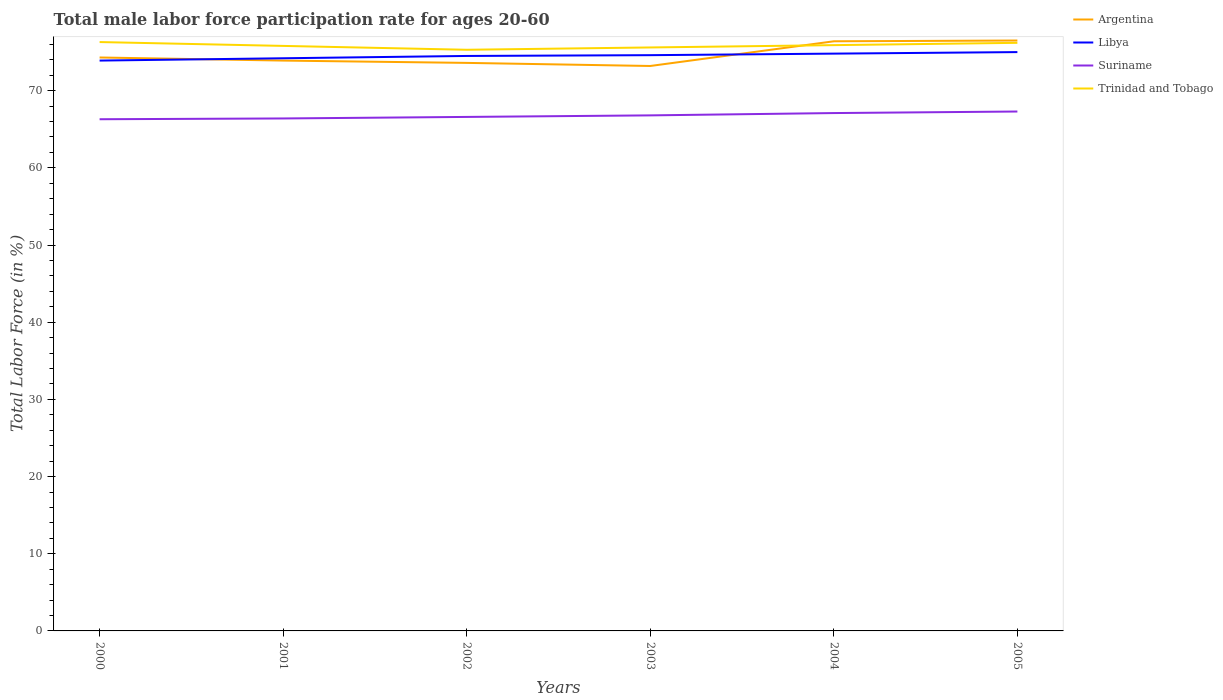Does the line corresponding to Trinidad and Tobago intersect with the line corresponding to Suriname?
Provide a short and direct response. No. Is the number of lines equal to the number of legend labels?
Make the answer very short. Yes. Across all years, what is the maximum male labor force participation rate in Argentina?
Keep it short and to the point. 73.2. What is the total male labor force participation rate in Suriname in the graph?
Your response must be concise. -0.3. What is the difference between the highest and the second highest male labor force participation rate in Libya?
Provide a short and direct response. 1.1. What is the difference between the highest and the lowest male labor force participation rate in Trinidad and Tobago?
Give a very brief answer. 3. How many lines are there?
Ensure brevity in your answer.  4. Where does the legend appear in the graph?
Provide a succinct answer. Top right. How many legend labels are there?
Provide a succinct answer. 4. What is the title of the graph?
Provide a succinct answer. Total male labor force participation rate for ages 20-60. Does "Ireland" appear as one of the legend labels in the graph?
Ensure brevity in your answer.  No. What is the label or title of the X-axis?
Offer a very short reply. Years. What is the label or title of the Y-axis?
Provide a short and direct response. Total Labor Force (in %). What is the Total Labor Force (in %) of Argentina in 2000?
Provide a short and direct response. 74.3. What is the Total Labor Force (in %) in Libya in 2000?
Give a very brief answer. 73.9. What is the Total Labor Force (in %) of Suriname in 2000?
Provide a short and direct response. 66.3. What is the Total Labor Force (in %) of Trinidad and Tobago in 2000?
Offer a terse response. 76.3. What is the Total Labor Force (in %) of Argentina in 2001?
Provide a short and direct response. 73.9. What is the Total Labor Force (in %) in Libya in 2001?
Make the answer very short. 74.2. What is the Total Labor Force (in %) in Suriname in 2001?
Offer a terse response. 66.4. What is the Total Labor Force (in %) in Trinidad and Tobago in 2001?
Keep it short and to the point. 75.8. What is the Total Labor Force (in %) of Argentina in 2002?
Make the answer very short. 73.6. What is the Total Labor Force (in %) in Libya in 2002?
Provide a succinct answer. 74.5. What is the Total Labor Force (in %) of Suriname in 2002?
Give a very brief answer. 66.6. What is the Total Labor Force (in %) in Trinidad and Tobago in 2002?
Make the answer very short. 75.3. What is the Total Labor Force (in %) of Argentina in 2003?
Make the answer very short. 73.2. What is the Total Labor Force (in %) of Libya in 2003?
Ensure brevity in your answer.  74.6. What is the Total Labor Force (in %) of Suriname in 2003?
Your response must be concise. 66.8. What is the Total Labor Force (in %) in Trinidad and Tobago in 2003?
Ensure brevity in your answer.  75.6. What is the Total Labor Force (in %) of Argentina in 2004?
Your response must be concise. 76.4. What is the Total Labor Force (in %) of Libya in 2004?
Keep it short and to the point. 74.8. What is the Total Labor Force (in %) of Suriname in 2004?
Ensure brevity in your answer.  67.1. What is the Total Labor Force (in %) in Trinidad and Tobago in 2004?
Ensure brevity in your answer.  75.9. What is the Total Labor Force (in %) in Argentina in 2005?
Make the answer very short. 76.5. What is the Total Labor Force (in %) of Suriname in 2005?
Make the answer very short. 67.3. What is the Total Labor Force (in %) in Trinidad and Tobago in 2005?
Your answer should be very brief. 76.2. Across all years, what is the maximum Total Labor Force (in %) of Argentina?
Your response must be concise. 76.5. Across all years, what is the maximum Total Labor Force (in %) of Suriname?
Provide a short and direct response. 67.3. Across all years, what is the maximum Total Labor Force (in %) in Trinidad and Tobago?
Make the answer very short. 76.3. Across all years, what is the minimum Total Labor Force (in %) of Argentina?
Ensure brevity in your answer.  73.2. Across all years, what is the minimum Total Labor Force (in %) of Libya?
Your response must be concise. 73.9. Across all years, what is the minimum Total Labor Force (in %) in Suriname?
Your response must be concise. 66.3. Across all years, what is the minimum Total Labor Force (in %) in Trinidad and Tobago?
Ensure brevity in your answer.  75.3. What is the total Total Labor Force (in %) of Argentina in the graph?
Your answer should be very brief. 447.9. What is the total Total Labor Force (in %) of Libya in the graph?
Your answer should be compact. 447. What is the total Total Labor Force (in %) of Suriname in the graph?
Your answer should be compact. 400.5. What is the total Total Labor Force (in %) in Trinidad and Tobago in the graph?
Keep it short and to the point. 455.1. What is the difference between the Total Labor Force (in %) in Argentina in 2000 and that in 2001?
Provide a short and direct response. 0.4. What is the difference between the Total Labor Force (in %) of Libya in 2000 and that in 2001?
Make the answer very short. -0.3. What is the difference between the Total Labor Force (in %) in Libya in 2000 and that in 2002?
Provide a short and direct response. -0.6. What is the difference between the Total Labor Force (in %) in Suriname in 2000 and that in 2002?
Offer a very short reply. -0.3. What is the difference between the Total Labor Force (in %) of Trinidad and Tobago in 2000 and that in 2002?
Make the answer very short. 1. What is the difference between the Total Labor Force (in %) of Libya in 2000 and that in 2003?
Keep it short and to the point. -0.7. What is the difference between the Total Labor Force (in %) in Argentina in 2000 and that in 2004?
Give a very brief answer. -2.1. What is the difference between the Total Labor Force (in %) in Libya in 2000 and that in 2004?
Your answer should be very brief. -0.9. What is the difference between the Total Labor Force (in %) of Suriname in 2000 and that in 2004?
Provide a succinct answer. -0.8. What is the difference between the Total Labor Force (in %) of Trinidad and Tobago in 2000 and that in 2004?
Give a very brief answer. 0.4. What is the difference between the Total Labor Force (in %) in Argentina in 2000 and that in 2005?
Give a very brief answer. -2.2. What is the difference between the Total Labor Force (in %) of Argentina in 2001 and that in 2002?
Offer a terse response. 0.3. What is the difference between the Total Labor Force (in %) of Libya in 2001 and that in 2002?
Offer a terse response. -0.3. What is the difference between the Total Labor Force (in %) of Trinidad and Tobago in 2001 and that in 2002?
Offer a terse response. 0.5. What is the difference between the Total Labor Force (in %) of Trinidad and Tobago in 2001 and that in 2003?
Offer a terse response. 0.2. What is the difference between the Total Labor Force (in %) of Libya in 2001 and that in 2004?
Provide a succinct answer. -0.6. What is the difference between the Total Labor Force (in %) of Suriname in 2001 and that in 2004?
Your answer should be compact. -0.7. What is the difference between the Total Labor Force (in %) of Argentina in 2001 and that in 2005?
Keep it short and to the point. -2.6. What is the difference between the Total Labor Force (in %) of Trinidad and Tobago in 2001 and that in 2005?
Make the answer very short. -0.4. What is the difference between the Total Labor Force (in %) of Libya in 2002 and that in 2003?
Keep it short and to the point. -0.1. What is the difference between the Total Labor Force (in %) of Suriname in 2002 and that in 2003?
Provide a short and direct response. -0.2. What is the difference between the Total Labor Force (in %) in Trinidad and Tobago in 2002 and that in 2003?
Provide a succinct answer. -0.3. What is the difference between the Total Labor Force (in %) in Libya in 2002 and that in 2004?
Your answer should be very brief. -0.3. What is the difference between the Total Labor Force (in %) in Suriname in 2002 and that in 2004?
Make the answer very short. -0.5. What is the difference between the Total Labor Force (in %) in Argentina in 2002 and that in 2005?
Keep it short and to the point. -2.9. What is the difference between the Total Labor Force (in %) of Suriname in 2002 and that in 2005?
Offer a terse response. -0.7. What is the difference between the Total Labor Force (in %) of Libya in 2003 and that in 2004?
Offer a very short reply. -0.2. What is the difference between the Total Labor Force (in %) in Suriname in 2003 and that in 2004?
Your answer should be very brief. -0.3. What is the difference between the Total Labor Force (in %) in Trinidad and Tobago in 2003 and that in 2004?
Provide a succinct answer. -0.3. What is the difference between the Total Labor Force (in %) in Argentina in 2004 and that in 2005?
Offer a terse response. -0.1. What is the difference between the Total Labor Force (in %) of Libya in 2004 and that in 2005?
Make the answer very short. -0.2. What is the difference between the Total Labor Force (in %) of Suriname in 2004 and that in 2005?
Your answer should be compact. -0.2. What is the difference between the Total Labor Force (in %) of Trinidad and Tobago in 2004 and that in 2005?
Your answer should be very brief. -0.3. What is the difference between the Total Labor Force (in %) in Argentina in 2000 and the Total Labor Force (in %) in Libya in 2001?
Provide a short and direct response. 0.1. What is the difference between the Total Labor Force (in %) in Argentina in 2000 and the Total Labor Force (in %) in Trinidad and Tobago in 2001?
Offer a terse response. -1.5. What is the difference between the Total Labor Force (in %) in Libya in 2000 and the Total Labor Force (in %) in Trinidad and Tobago in 2001?
Offer a very short reply. -1.9. What is the difference between the Total Labor Force (in %) of Suriname in 2000 and the Total Labor Force (in %) of Trinidad and Tobago in 2001?
Ensure brevity in your answer.  -9.5. What is the difference between the Total Labor Force (in %) of Argentina in 2000 and the Total Labor Force (in %) of Suriname in 2002?
Provide a succinct answer. 7.7. What is the difference between the Total Labor Force (in %) of Argentina in 2000 and the Total Labor Force (in %) of Trinidad and Tobago in 2002?
Keep it short and to the point. -1. What is the difference between the Total Labor Force (in %) of Libya in 2000 and the Total Labor Force (in %) of Suriname in 2002?
Make the answer very short. 7.3. What is the difference between the Total Labor Force (in %) of Libya in 2000 and the Total Labor Force (in %) of Trinidad and Tobago in 2002?
Offer a very short reply. -1.4. What is the difference between the Total Labor Force (in %) of Suriname in 2000 and the Total Labor Force (in %) of Trinidad and Tobago in 2002?
Ensure brevity in your answer.  -9. What is the difference between the Total Labor Force (in %) of Argentina in 2000 and the Total Labor Force (in %) of Libya in 2003?
Offer a very short reply. -0.3. What is the difference between the Total Labor Force (in %) of Libya in 2000 and the Total Labor Force (in %) of Trinidad and Tobago in 2003?
Your response must be concise. -1.7. What is the difference between the Total Labor Force (in %) of Suriname in 2000 and the Total Labor Force (in %) of Trinidad and Tobago in 2003?
Your answer should be very brief. -9.3. What is the difference between the Total Labor Force (in %) of Argentina in 2000 and the Total Labor Force (in %) of Libya in 2004?
Your response must be concise. -0.5. What is the difference between the Total Labor Force (in %) of Argentina in 2000 and the Total Labor Force (in %) of Suriname in 2004?
Make the answer very short. 7.2. What is the difference between the Total Labor Force (in %) in Argentina in 2000 and the Total Labor Force (in %) in Trinidad and Tobago in 2004?
Your response must be concise. -1.6. What is the difference between the Total Labor Force (in %) of Libya in 2000 and the Total Labor Force (in %) of Trinidad and Tobago in 2004?
Give a very brief answer. -2. What is the difference between the Total Labor Force (in %) of Suriname in 2000 and the Total Labor Force (in %) of Trinidad and Tobago in 2004?
Your response must be concise. -9.6. What is the difference between the Total Labor Force (in %) in Argentina in 2000 and the Total Labor Force (in %) in Libya in 2005?
Offer a very short reply. -0.7. What is the difference between the Total Labor Force (in %) in Argentina in 2000 and the Total Labor Force (in %) in Suriname in 2005?
Offer a very short reply. 7. What is the difference between the Total Labor Force (in %) in Argentina in 2000 and the Total Labor Force (in %) in Trinidad and Tobago in 2005?
Provide a short and direct response. -1.9. What is the difference between the Total Labor Force (in %) of Libya in 2000 and the Total Labor Force (in %) of Suriname in 2005?
Offer a very short reply. 6.6. What is the difference between the Total Labor Force (in %) of Libya in 2000 and the Total Labor Force (in %) of Trinidad and Tobago in 2005?
Your response must be concise. -2.3. What is the difference between the Total Labor Force (in %) of Argentina in 2001 and the Total Labor Force (in %) of Trinidad and Tobago in 2002?
Your answer should be very brief. -1.4. What is the difference between the Total Labor Force (in %) in Libya in 2001 and the Total Labor Force (in %) in Trinidad and Tobago in 2002?
Provide a short and direct response. -1.1. What is the difference between the Total Labor Force (in %) of Argentina in 2001 and the Total Labor Force (in %) of Suriname in 2003?
Provide a short and direct response. 7.1. What is the difference between the Total Labor Force (in %) of Argentina in 2001 and the Total Labor Force (in %) of Trinidad and Tobago in 2003?
Provide a succinct answer. -1.7. What is the difference between the Total Labor Force (in %) of Libya in 2001 and the Total Labor Force (in %) of Suriname in 2003?
Offer a terse response. 7.4. What is the difference between the Total Labor Force (in %) of Argentina in 2001 and the Total Labor Force (in %) of Trinidad and Tobago in 2004?
Provide a short and direct response. -2. What is the difference between the Total Labor Force (in %) of Libya in 2001 and the Total Labor Force (in %) of Suriname in 2004?
Offer a very short reply. 7.1. What is the difference between the Total Labor Force (in %) in Libya in 2001 and the Total Labor Force (in %) in Trinidad and Tobago in 2004?
Your answer should be very brief. -1.7. What is the difference between the Total Labor Force (in %) in Suriname in 2001 and the Total Labor Force (in %) in Trinidad and Tobago in 2004?
Your response must be concise. -9.5. What is the difference between the Total Labor Force (in %) of Argentina in 2001 and the Total Labor Force (in %) of Suriname in 2005?
Give a very brief answer. 6.6. What is the difference between the Total Labor Force (in %) of Suriname in 2001 and the Total Labor Force (in %) of Trinidad and Tobago in 2005?
Ensure brevity in your answer.  -9.8. What is the difference between the Total Labor Force (in %) in Argentina in 2002 and the Total Labor Force (in %) in Libya in 2004?
Offer a terse response. -1.2. What is the difference between the Total Labor Force (in %) in Libya in 2002 and the Total Labor Force (in %) in Suriname in 2004?
Offer a terse response. 7.4. What is the difference between the Total Labor Force (in %) in Suriname in 2002 and the Total Labor Force (in %) in Trinidad and Tobago in 2004?
Offer a terse response. -9.3. What is the difference between the Total Labor Force (in %) in Argentina in 2002 and the Total Labor Force (in %) in Suriname in 2005?
Your answer should be compact. 6.3. What is the difference between the Total Labor Force (in %) of Argentina in 2002 and the Total Labor Force (in %) of Trinidad and Tobago in 2005?
Your response must be concise. -2.6. What is the difference between the Total Labor Force (in %) of Libya in 2002 and the Total Labor Force (in %) of Trinidad and Tobago in 2005?
Make the answer very short. -1.7. What is the difference between the Total Labor Force (in %) of Suriname in 2002 and the Total Labor Force (in %) of Trinidad and Tobago in 2005?
Ensure brevity in your answer.  -9.6. What is the difference between the Total Labor Force (in %) of Argentina in 2003 and the Total Labor Force (in %) of Libya in 2004?
Offer a terse response. -1.6. What is the difference between the Total Labor Force (in %) of Suriname in 2003 and the Total Labor Force (in %) of Trinidad and Tobago in 2004?
Make the answer very short. -9.1. What is the difference between the Total Labor Force (in %) in Argentina in 2003 and the Total Labor Force (in %) in Suriname in 2005?
Offer a very short reply. 5.9. What is the difference between the Total Labor Force (in %) in Argentina in 2003 and the Total Labor Force (in %) in Trinidad and Tobago in 2005?
Offer a very short reply. -3. What is the difference between the Total Labor Force (in %) in Argentina in 2004 and the Total Labor Force (in %) in Libya in 2005?
Ensure brevity in your answer.  1.4. What is the difference between the Total Labor Force (in %) of Argentina in 2004 and the Total Labor Force (in %) of Trinidad and Tobago in 2005?
Your response must be concise. 0.2. What is the average Total Labor Force (in %) of Argentina per year?
Keep it short and to the point. 74.65. What is the average Total Labor Force (in %) of Libya per year?
Offer a terse response. 74.5. What is the average Total Labor Force (in %) of Suriname per year?
Keep it short and to the point. 66.75. What is the average Total Labor Force (in %) of Trinidad and Tobago per year?
Your answer should be very brief. 75.85. In the year 2000, what is the difference between the Total Labor Force (in %) of Argentina and Total Labor Force (in %) of Libya?
Your answer should be very brief. 0.4. In the year 2000, what is the difference between the Total Labor Force (in %) of Argentina and Total Labor Force (in %) of Trinidad and Tobago?
Your answer should be very brief. -2. In the year 2000, what is the difference between the Total Labor Force (in %) in Libya and Total Labor Force (in %) in Suriname?
Provide a short and direct response. 7.6. In the year 2000, what is the difference between the Total Labor Force (in %) of Libya and Total Labor Force (in %) of Trinidad and Tobago?
Your answer should be very brief. -2.4. In the year 2000, what is the difference between the Total Labor Force (in %) in Suriname and Total Labor Force (in %) in Trinidad and Tobago?
Keep it short and to the point. -10. In the year 2001, what is the difference between the Total Labor Force (in %) of Argentina and Total Labor Force (in %) of Libya?
Your answer should be compact. -0.3. In the year 2001, what is the difference between the Total Labor Force (in %) in Argentina and Total Labor Force (in %) in Suriname?
Offer a very short reply. 7.5. In the year 2001, what is the difference between the Total Labor Force (in %) of Libya and Total Labor Force (in %) of Suriname?
Ensure brevity in your answer.  7.8. In the year 2001, what is the difference between the Total Labor Force (in %) in Suriname and Total Labor Force (in %) in Trinidad and Tobago?
Your answer should be very brief. -9.4. In the year 2002, what is the difference between the Total Labor Force (in %) of Argentina and Total Labor Force (in %) of Trinidad and Tobago?
Your answer should be compact. -1.7. In the year 2003, what is the difference between the Total Labor Force (in %) in Argentina and Total Labor Force (in %) in Libya?
Your response must be concise. -1.4. In the year 2003, what is the difference between the Total Labor Force (in %) in Libya and Total Labor Force (in %) in Trinidad and Tobago?
Offer a very short reply. -1. In the year 2004, what is the difference between the Total Labor Force (in %) of Libya and Total Labor Force (in %) of Trinidad and Tobago?
Your answer should be very brief. -1.1. In the year 2005, what is the difference between the Total Labor Force (in %) in Argentina and Total Labor Force (in %) in Libya?
Provide a short and direct response. 1.5. In the year 2005, what is the difference between the Total Labor Force (in %) of Argentina and Total Labor Force (in %) of Trinidad and Tobago?
Keep it short and to the point. 0.3. In the year 2005, what is the difference between the Total Labor Force (in %) of Libya and Total Labor Force (in %) of Suriname?
Offer a very short reply. 7.7. In the year 2005, what is the difference between the Total Labor Force (in %) of Suriname and Total Labor Force (in %) of Trinidad and Tobago?
Keep it short and to the point. -8.9. What is the ratio of the Total Labor Force (in %) of Argentina in 2000 to that in 2001?
Your answer should be very brief. 1.01. What is the ratio of the Total Labor Force (in %) in Libya in 2000 to that in 2001?
Keep it short and to the point. 1. What is the ratio of the Total Labor Force (in %) in Trinidad and Tobago in 2000 to that in 2001?
Your response must be concise. 1.01. What is the ratio of the Total Labor Force (in %) of Argentina in 2000 to that in 2002?
Your response must be concise. 1.01. What is the ratio of the Total Labor Force (in %) of Libya in 2000 to that in 2002?
Provide a succinct answer. 0.99. What is the ratio of the Total Labor Force (in %) of Trinidad and Tobago in 2000 to that in 2002?
Give a very brief answer. 1.01. What is the ratio of the Total Labor Force (in %) in Libya in 2000 to that in 2003?
Provide a short and direct response. 0.99. What is the ratio of the Total Labor Force (in %) in Trinidad and Tobago in 2000 to that in 2003?
Provide a short and direct response. 1.01. What is the ratio of the Total Labor Force (in %) in Argentina in 2000 to that in 2004?
Ensure brevity in your answer.  0.97. What is the ratio of the Total Labor Force (in %) in Libya in 2000 to that in 2004?
Your answer should be very brief. 0.99. What is the ratio of the Total Labor Force (in %) in Suriname in 2000 to that in 2004?
Provide a succinct answer. 0.99. What is the ratio of the Total Labor Force (in %) of Argentina in 2000 to that in 2005?
Offer a very short reply. 0.97. What is the ratio of the Total Labor Force (in %) in Libya in 2000 to that in 2005?
Provide a succinct answer. 0.99. What is the ratio of the Total Labor Force (in %) in Suriname in 2000 to that in 2005?
Provide a short and direct response. 0.99. What is the ratio of the Total Labor Force (in %) of Trinidad and Tobago in 2000 to that in 2005?
Your answer should be compact. 1. What is the ratio of the Total Labor Force (in %) of Argentina in 2001 to that in 2002?
Your answer should be compact. 1. What is the ratio of the Total Labor Force (in %) of Suriname in 2001 to that in 2002?
Make the answer very short. 1. What is the ratio of the Total Labor Force (in %) in Trinidad and Tobago in 2001 to that in 2002?
Your response must be concise. 1.01. What is the ratio of the Total Labor Force (in %) in Argentina in 2001 to that in 2003?
Provide a succinct answer. 1.01. What is the ratio of the Total Labor Force (in %) in Trinidad and Tobago in 2001 to that in 2003?
Your response must be concise. 1. What is the ratio of the Total Labor Force (in %) in Argentina in 2001 to that in 2004?
Your answer should be compact. 0.97. What is the ratio of the Total Labor Force (in %) of Libya in 2001 to that in 2004?
Ensure brevity in your answer.  0.99. What is the ratio of the Total Labor Force (in %) in Trinidad and Tobago in 2001 to that in 2004?
Ensure brevity in your answer.  1. What is the ratio of the Total Labor Force (in %) in Libya in 2001 to that in 2005?
Keep it short and to the point. 0.99. What is the ratio of the Total Labor Force (in %) of Suriname in 2001 to that in 2005?
Your answer should be very brief. 0.99. What is the ratio of the Total Labor Force (in %) of Trinidad and Tobago in 2001 to that in 2005?
Your answer should be compact. 0.99. What is the ratio of the Total Labor Force (in %) of Trinidad and Tobago in 2002 to that in 2003?
Provide a succinct answer. 1. What is the ratio of the Total Labor Force (in %) in Argentina in 2002 to that in 2004?
Give a very brief answer. 0.96. What is the ratio of the Total Labor Force (in %) in Libya in 2002 to that in 2004?
Keep it short and to the point. 1. What is the ratio of the Total Labor Force (in %) of Argentina in 2002 to that in 2005?
Provide a succinct answer. 0.96. What is the ratio of the Total Labor Force (in %) of Libya in 2002 to that in 2005?
Ensure brevity in your answer.  0.99. What is the ratio of the Total Labor Force (in %) in Trinidad and Tobago in 2002 to that in 2005?
Your answer should be very brief. 0.99. What is the ratio of the Total Labor Force (in %) of Argentina in 2003 to that in 2004?
Offer a terse response. 0.96. What is the ratio of the Total Labor Force (in %) of Libya in 2003 to that in 2004?
Provide a short and direct response. 1. What is the ratio of the Total Labor Force (in %) in Suriname in 2003 to that in 2004?
Give a very brief answer. 1. What is the ratio of the Total Labor Force (in %) in Trinidad and Tobago in 2003 to that in 2004?
Your answer should be very brief. 1. What is the ratio of the Total Labor Force (in %) of Argentina in 2003 to that in 2005?
Your answer should be compact. 0.96. What is the ratio of the Total Labor Force (in %) of Libya in 2003 to that in 2005?
Your response must be concise. 0.99. What is the ratio of the Total Labor Force (in %) in Suriname in 2003 to that in 2005?
Your answer should be very brief. 0.99. What is the ratio of the Total Labor Force (in %) of Trinidad and Tobago in 2003 to that in 2005?
Offer a very short reply. 0.99. What is the ratio of the Total Labor Force (in %) of Argentina in 2004 to that in 2005?
Provide a succinct answer. 1. What is the ratio of the Total Labor Force (in %) of Libya in 2004 to that in 2005?
Your answer should be compact. 1. What is the ratio of the Total Labor Force (in %) of Suriname in 2004 to that in 2005?
Give a very brief answer. 1. What is the difference between the highest and the second highest Total Labor Force (in %) of Libya?
Make the answer very short. 0.2. What is the difference between the highest and the second highest Total Labor Force (in %) in Suriname?
Offer a terse response. 0.2. What is the difference between the highest and the lowest Total Labor Force (in %) in Argentina?
Give a very brief answer. 3.3. What is the difference between the highest and the lowest Total Labor Force (in %) of Libya?
Make the answer very short. 1.1. What is the difference between the highest and the lowest Total Labor Force (in %) of Suriname?
Make the answer very short. 1. 